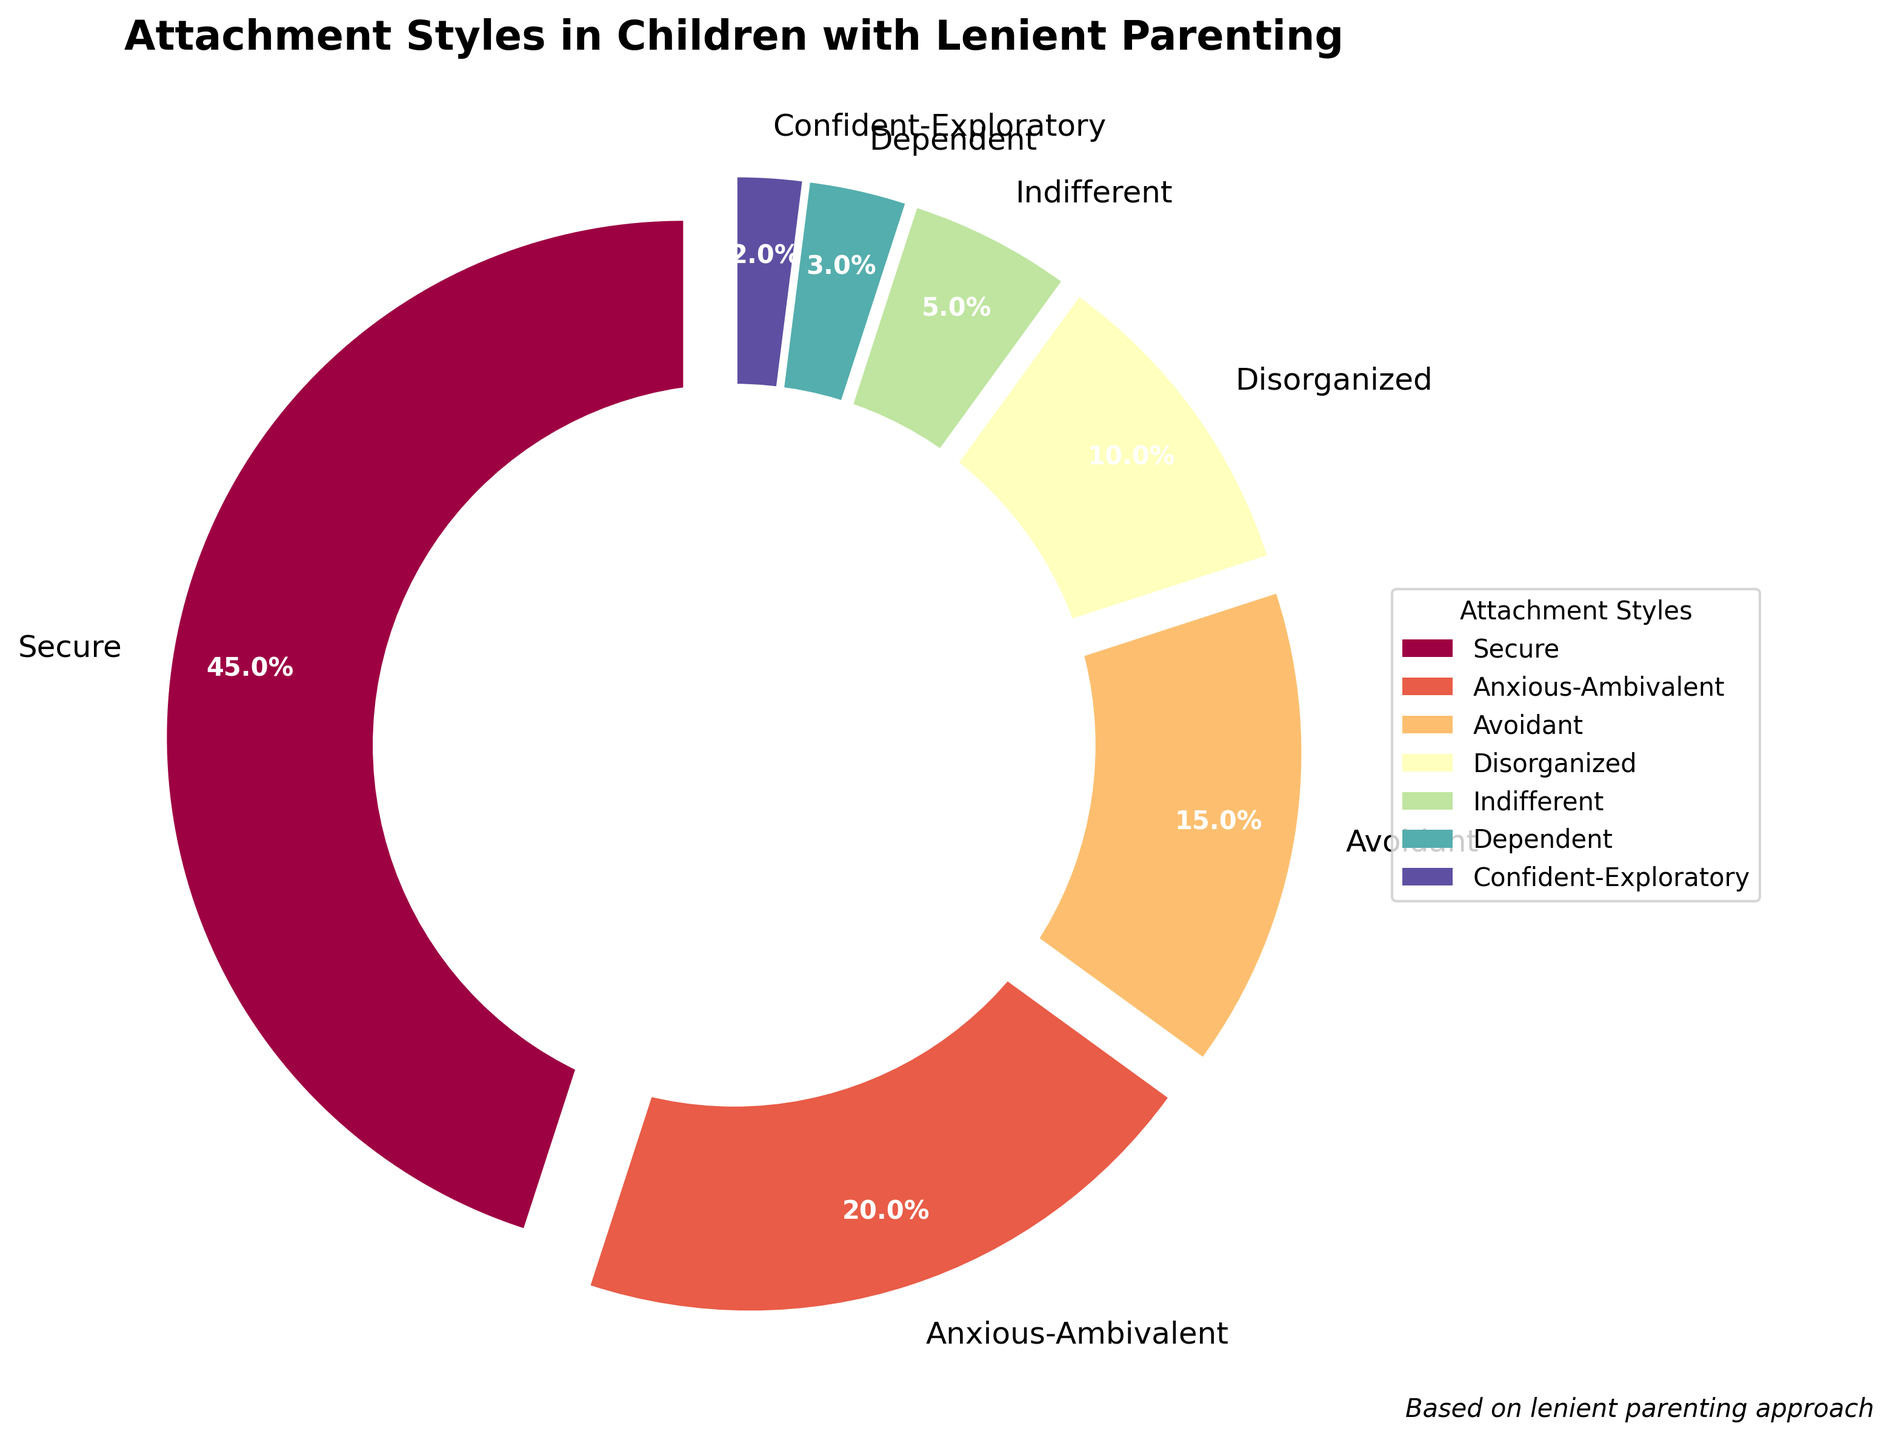Which attachment style is the most common among children raised with a lenient parenting approach? By looking at the figure, the largest segment in the pie chart represents the most common attachment style. The segment labeled "Secure" takes up the largest portion of the pie.
Answer: Secure What is the combined percentage of children with Anxious-Ambivalent and Avoidant attachment styles? The figure shows that Anxious-Ambivalent has a percentage of 20% and Avoidant has a percentage of 15%. Adding these together, 20% + 15% = 35%.
Answer: 35% Which attachment styles have a percentage less than 10%? From the figure, the styles with a percentage less than 10% are "Disorganized" at 10%, "Indifferent" at 5%, "Dependent" at 3%, and "Confident-Exploratory" at 2%. Only the last three meet the criteria.
Answer: Indifferent, Dependent, Confident-Exploratory Is the percentage of Secure attachment style more than double that of Avoidant attachment style? The Secure attachment style has a percentage of 45%, and the Avoidant attachment style has 15%. Since 45% is more than double 15% (double 15% is 30%), the statement is true.
Answer: Yes What is the difference in percentage between the smallest and the largest attachment styles? The smallest percentage is for Confident-Exploratory at 2%, and the largest is Secure at 45%. The difference is 45% - 2% = 43%.
Answer: 43% Which attachment style segment is represented with the lightest shade in the chart? Visually comparing the segments, the Confident-Exploratory style marked at 2% appears in the lightest shade of color in the chart.
Answer: Confident-Exploratory What is the total percentage of children with attachment styles other than Secure? The Secure attachment style accounts for 45%. Therefore, the total of non-Secure percentages is 100% - 45% = 55%.
Answer: 55% If lenient parenting were to change and cut the Disorganized attachment style in half, what would its new percentage be in the figure? The current percentage for Disorganized is 10%. Halving this would result in 10% / 2 = 5%.
Answer: 5% Compare the percentages of Anxious-Ambivalent and Indifferent attachment styles. Which one has a higher percentage and by how much? Anxious-Ambivalent has a percentage of 20%, and Indifferent has 5%. The difference is 20% - 5% = 15%.
Answer: Anxious-Ambivalent, 15% higher 